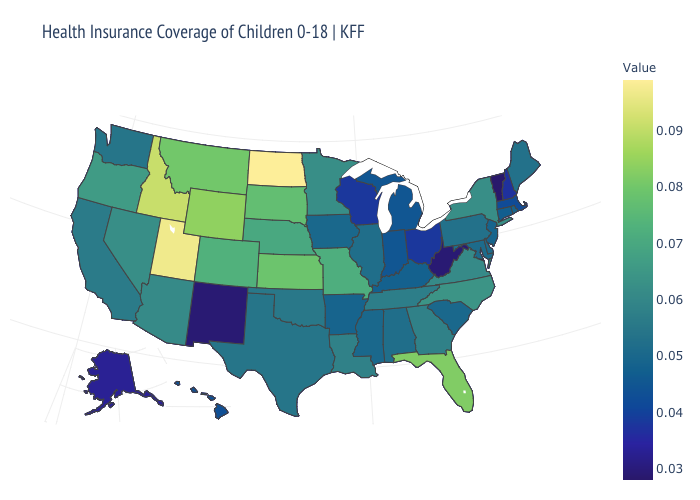Is the legend a continuous bar?
Short answer required. Yes. Does Iowa have a higher value than Missouri?
Answer briefly. No. Among the states that border New Jersey , does Pennsylvania have the highest value?
Short answer required. No. Among the states that border Colorado , which have the lowest value?
Concise answer only. New Mexico. Does North Dakota have the highest value in the USA?
Give a very brief answer. Yes. Among the states that border New Mexico , which have the highest value?
Keep it brief. Utah. Among the states that border Kansas , does Colorado have the lowest value?
Be succinct. No. 